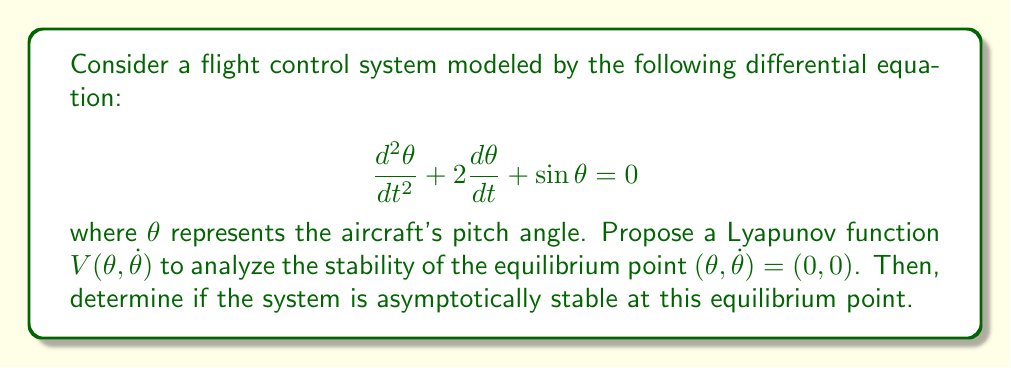Can you answer this question? To analyze the stability of the given flight control system, we'll follow these steps:

1) Propose a Lyapunov function:
   Let's consider the following Lyapunov function candidate:
   
   $$V(\theta, \dot{\theta}) = \frac{1}{2}\dot{\theta}^2 + 1 - \cos\theta$$

2) Verify that $V(\theta, \dot{\theta})$ is positive definite:
   - At equilibrium $(0, 0)$, $V(0, 0) = 0$
   - For any other point, $V(\theta, \dot{\theta}) > 0$, as $\frac{1}{2}\dot{\theta}^2 \geq 0$ and $1 - \cos\theta > 0$ for $\theta \neq 0$

3) Calculate the time derivative of $V$:
   
   $$\begin{align}
   \dot{V} &= \dot{\theta}\ddot{\theta} + \dot{\theta}\sin\theta \\
   &= \dot{\theta}(-2\dot{\theta} - \sin\theta) + \dot{\theta}\sin\theta \\
   &= -2\dot{\theta}^2
   \end{align}$$

4) Analyze $\dot{V}$:
   - $\dot{V}$ is negative semi-definite ($ \leq 0$ for all $\theta$ and $\dot{\theta}$)
   - $\dot{V} = 0$ only when $\dot{\theta} = 0$

5) Apply LaSalle's Invariance Principle:
   - The set where $\dot{V} = 0$ is $\{\theta, 0\}$
   - In this set, the system dynamics reduce to $\sin\theta = 0$
   - The only solution that can stay identically in this set is $\theta = 0$

Therefore, by LaSalle's Invariance Principle, the system is asymptotically stable at the equilibrium point $(0, 0)$.
Answer: Asymptotically stable 